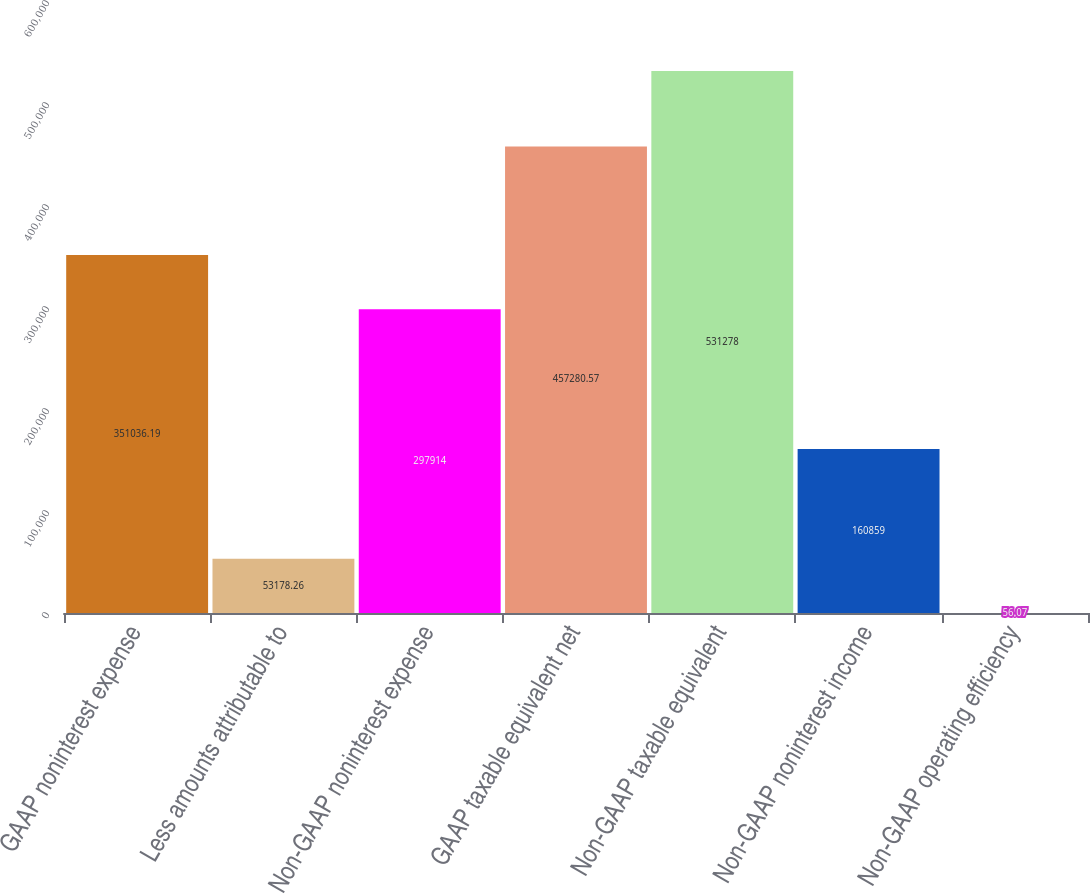Convert chart. <chart><loc_0><loc_0><loc_500><loc_500><bar_chart><fcel>GAAP noninterest expense<fcel>Less amounts attributable to<fcel>Non-GAAP noninterest expense<fcel>GAAP taxable equivalent net<fcel>Non-GAAP taxable equivalent<fcel>Non-GAAP noninterest income<fcel>Non-GAAP operating efficiency<nl><fcel>351036<fcel>53178.3<fcel>297914<fcel>457281<fcel>531278<fcel>160859<fcel>56.07<nl></chart> 